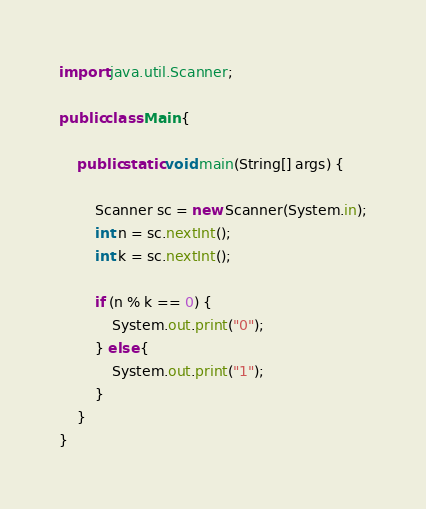Convert code to text. <code><loc_0><loc_0><loc_500><loc_500><_Java_>import java.util.Scanner;

public class Main {

	public static void main(String[] args) {

		Scanner sc = new Scanner(System.in);
		int n = sc.nextInt();
		int k = sc.nextInt();

		if (n % k == 0) {
			System.out.print("0");
		} else {
			System.out.print("1");
		}
	}
}</code> 